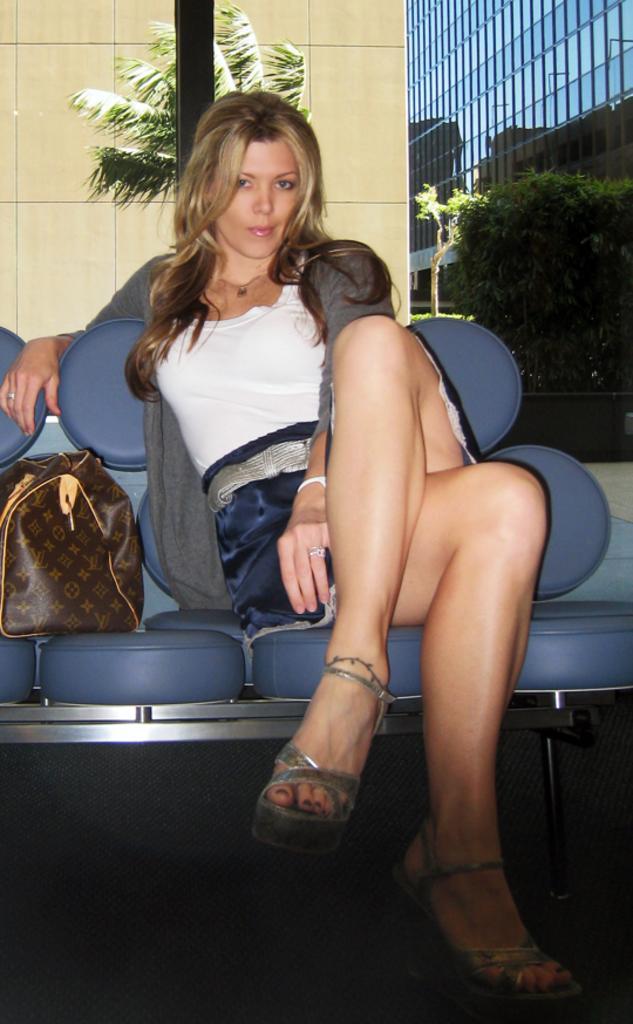Can you describe this image briefly? a lady sitting on a chair with a bag beside her 